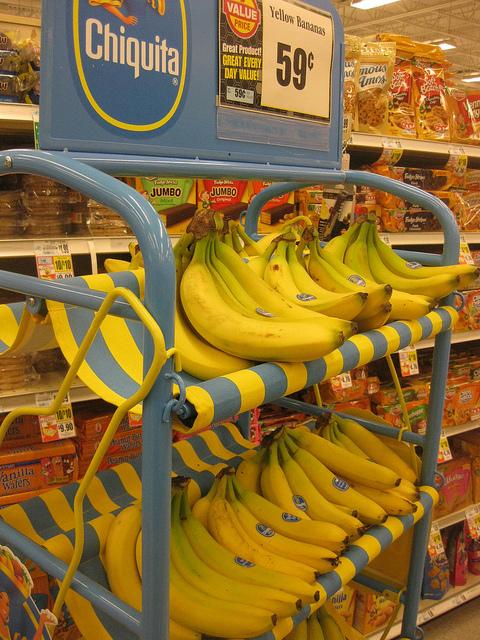How many bunches of bananas are there?
Be succinct. 7. What is in the picture?
Quick response, please. Bananas. Are the bananas ripe?
Short answer required. Yes. 